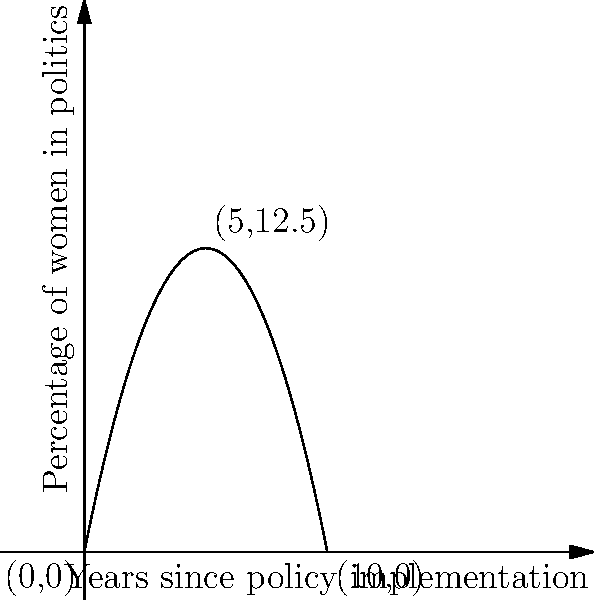The parabola shown represents the trajectory of women's representation in politics following the implementation of a progressive policy. The x-axis represents years since the policy was implemented, and the y-axis represents the percentage of women in politics. If the equation of this parabola is $y = -0.5x^2 + 5x$, at what year does women's representation reach its peak, and what is the maximum percentage achieved? To solve this problem, we need to follow these steps:

1) The general form of a parabola is $y = ax^2 + bx + c$, where $a$, $b$, and $c$ are constants and $a \neq 0$.

2) In this case, we have $y = -0.5x^2 + 5x$, so $a = -0.5$, $b = 5$, and $c = 0$.

3) For a parabola, the x-coordinate of the vertex represents the point where y reaches its maximum (or minimum if the parabola opens upward). The formula for the x-coordinate of the vertex is $x = -\frac{b}{2a}$.

4) Plugging in our values:
   $x = -\frac{5}{2(-0.5)} = -\frac{5}{-1} = 5$

5) This means that women's representation reaches its peak 5 years after the policy implementation.

6) To find the maximum percentage, we plug x = 5 into the original equation:
   $y = -0.5(5)^2 + 5(5)$
   $y = -0.5(25) + 25$
   $y = -12.5 + 25 = 12.5$

Therefore, the maximum percentage of women in politics is 12.5%.
Answer: 5 years; 12.5% 